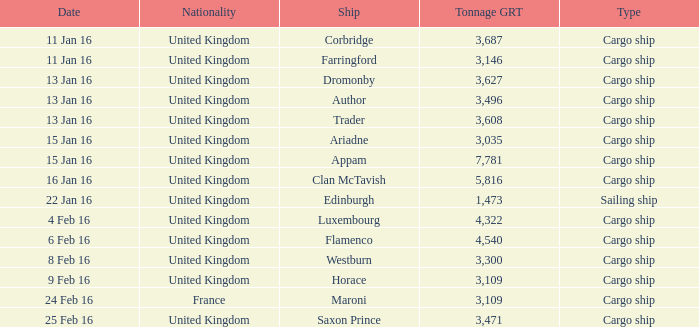What is the tonnage grt of the ship author? 3496.0. 